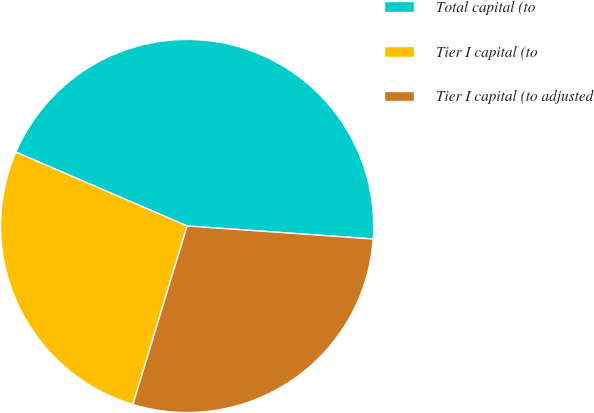Convert chart to OTSL. <chart><loc_0><loc_0><loc_500><loc_500><pie_chart><fcel>Total capital (to<fcel>Tier I capital (to<fcel>Tier I capital (to adjusted<nl><fcel>44.63%<fcel>26.79%<fcel>28.58%<nl></chart> 